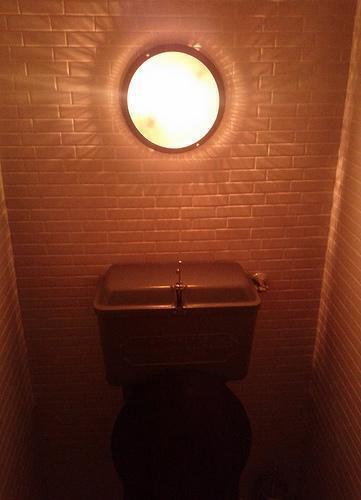How many holes are in the wall?
Give a very brief answer. 1. How many toilets are there?
Give a very brief answer. 1. 